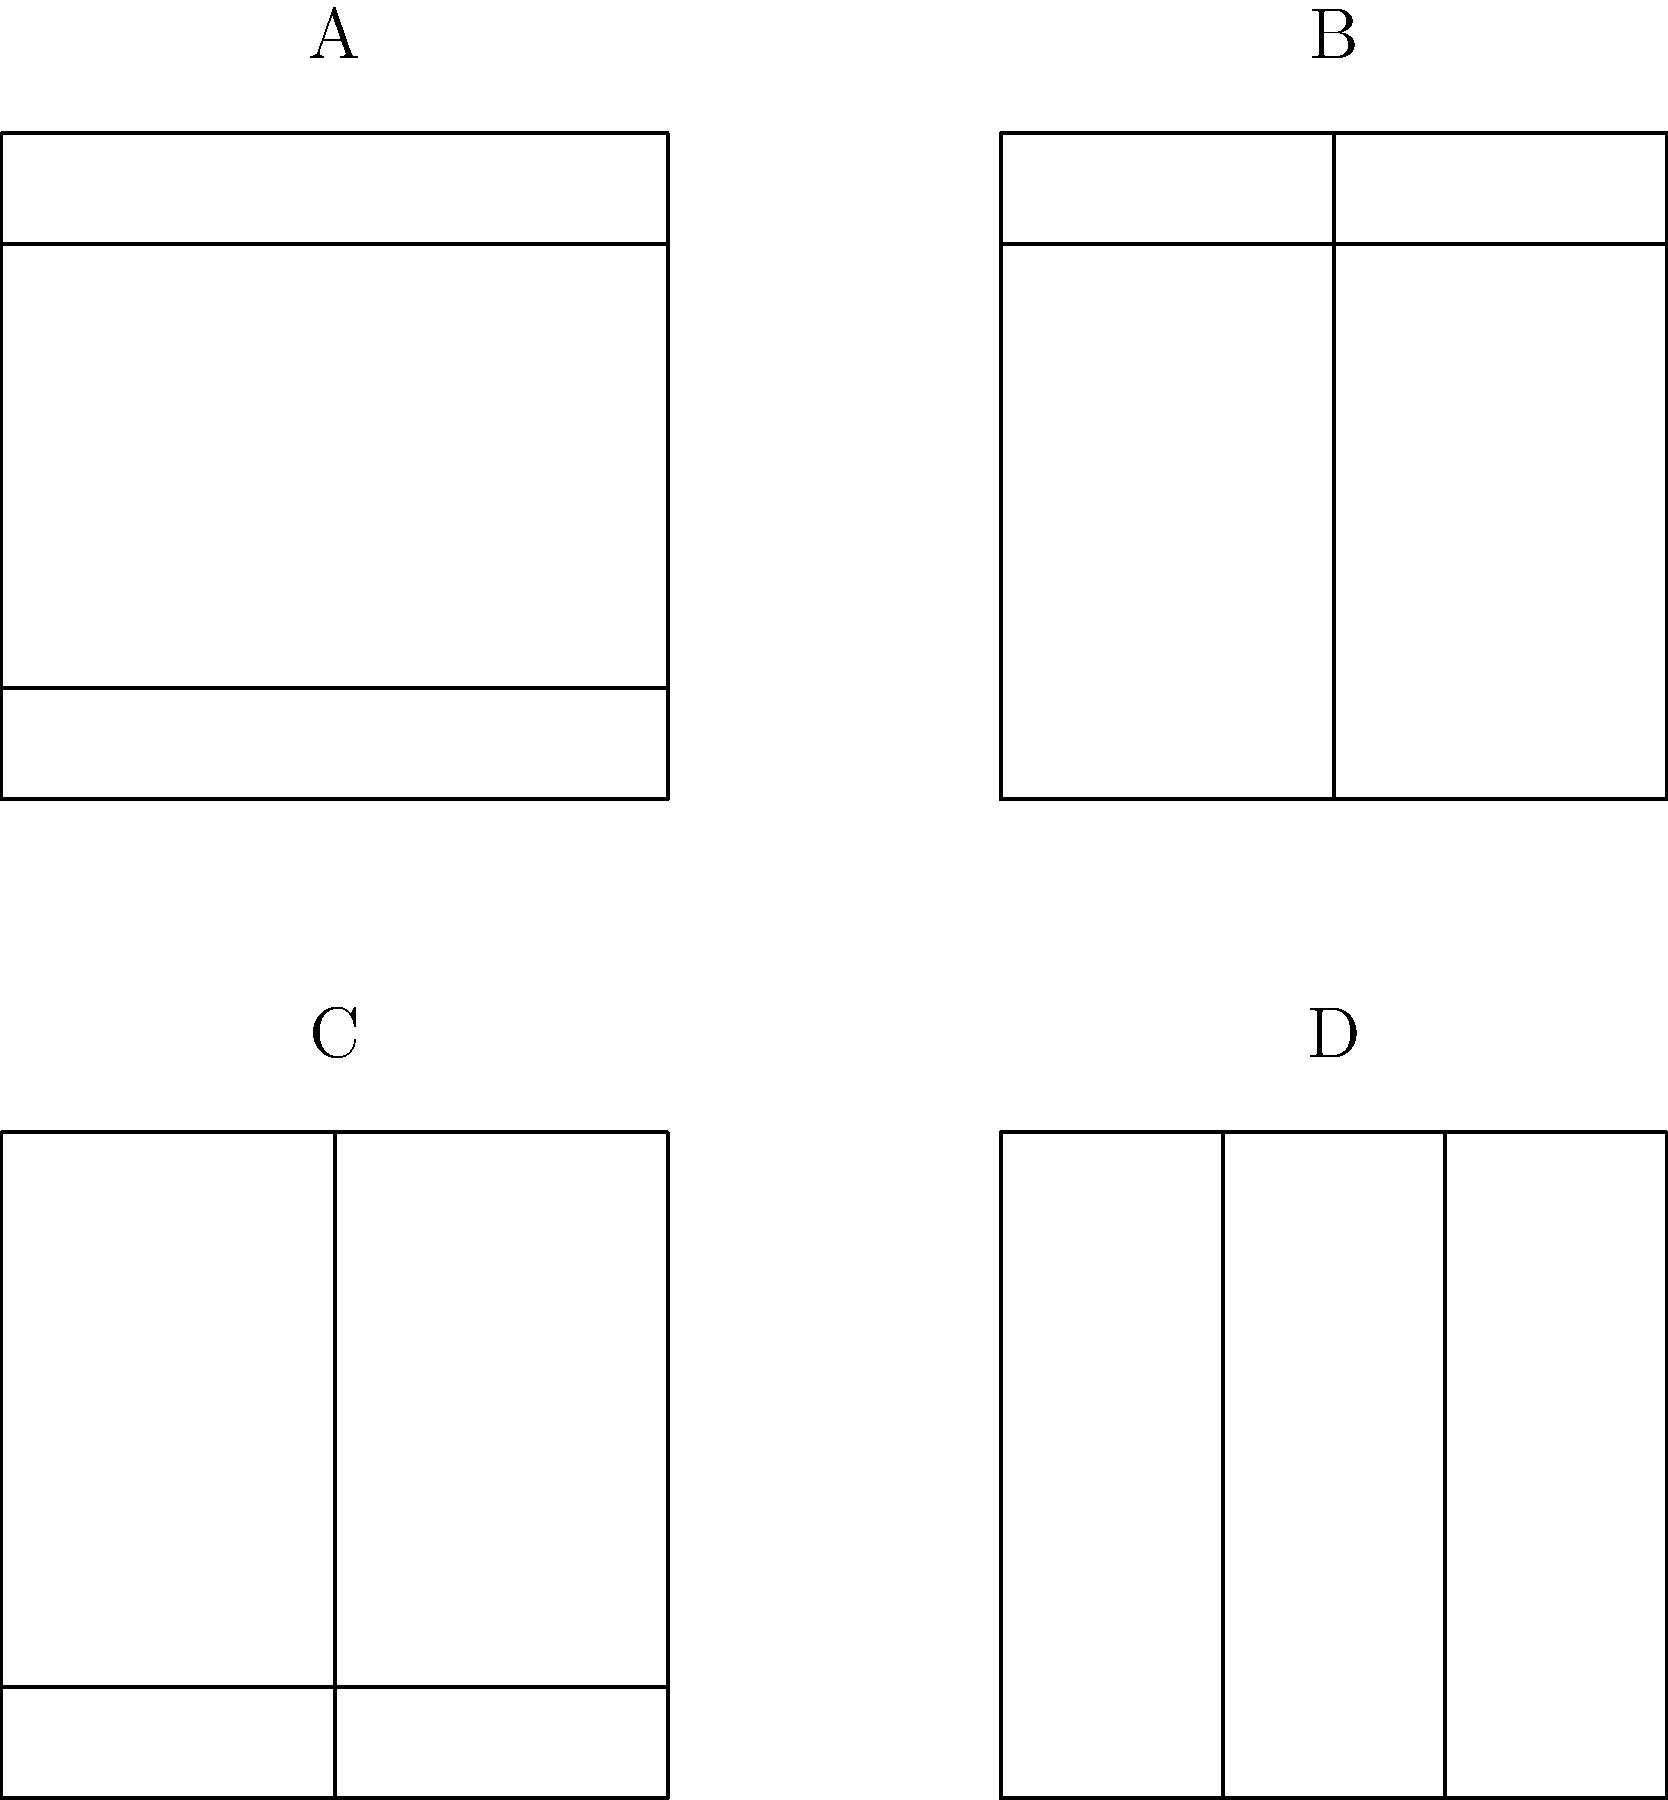As a UX designer specializing in survey interfaces, which of the above mockups (A, B, C, or D) would you consider the most visually appealing and user-friendly for an online survey? To determine the most visually appealing and user-friendly layout for an online survey, we need to consider several factors:

1. Structure: A clear structure helps users navigate the survey easily.
2. Balance: A well-balanced layout is more visually appealing and less overwhelming.
3. Responsiveness: A design that can adapt to different screen sizes is crucial for online surveys.

Let's analyze each mockup:

A: Has a header and footer, which provides clear structure. Single-column layout is simple but may not utilize space efficiently on larger screens.

B: Includes a header, which helps with navigation. Two-column layout balances space usage better than A. No footer might limit space for important information or navigation elements.

C: Two-column layout with a footer. Lacks a header, which may make navigation more difficult. The footer can house important links or information.

D: Three-column layout without header or footer. While it maximizes content display, it lacks clear structure and may be overwhelming for users.

Considering these factors, mockup B provides the best balance of structure, space utilization, and potential for responsiveness. The header allows for clear navigation and branding, while the two-column layout efficiently uses space and can easily adapt to different screen sizes. The absence of a footer allows for more flexibility in content placement.
Answer: B 